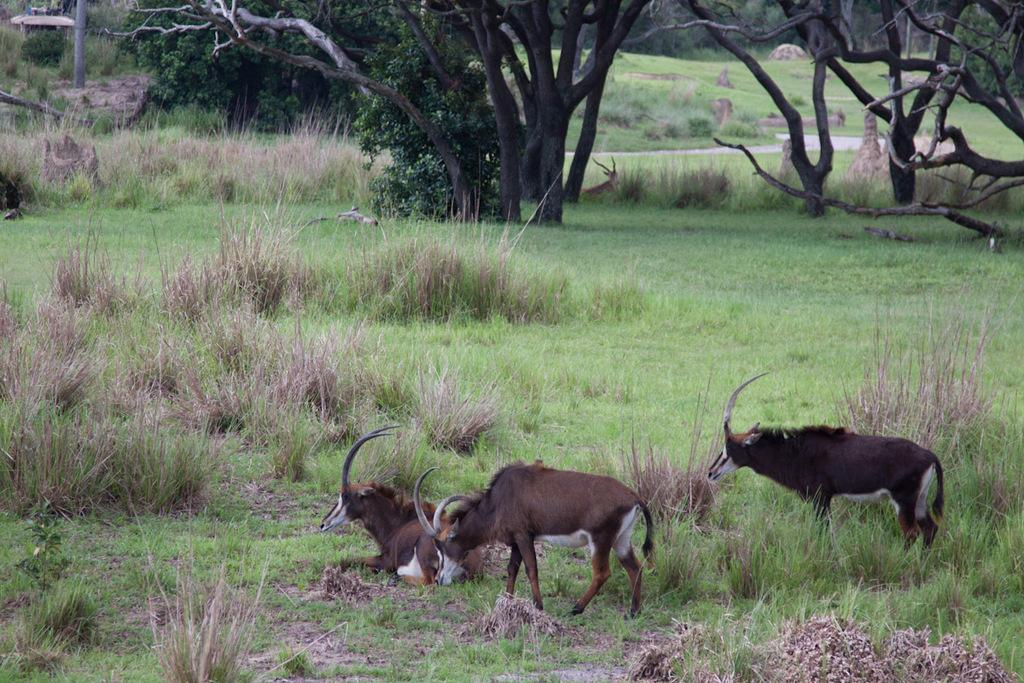How many animals are present in the image? There are three animals on the ground in the image. What type of surface do the animals appear to be standing on? The ground has grass. What can be seen in the background of the image? There are trees and plants in the background. Is there any grass visible in the background? Yes, there is grass on the ground in the background. What type of iron object can be seen in the image? There is no iron object present in the image. Is there any poison visible in the image? There is no poison present in the image. 